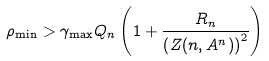<formula> <loc_0><loc_0><loc_500><loc_500>\rho _ { \min } > \gamma _ { \max } Q _ { n } \left ( 1 + \frac { R _ { n } } { \left ( Z ( n , A ^ { n } ) \right ) ^ { 2 } } \right )</formula> 